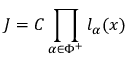<formula> <loc_0><loc_0><loc_500><loc_500>J = C \prod _ { \alpha \in \Phi ^ { + } } l _ { \alpha } ( x )</formula> 